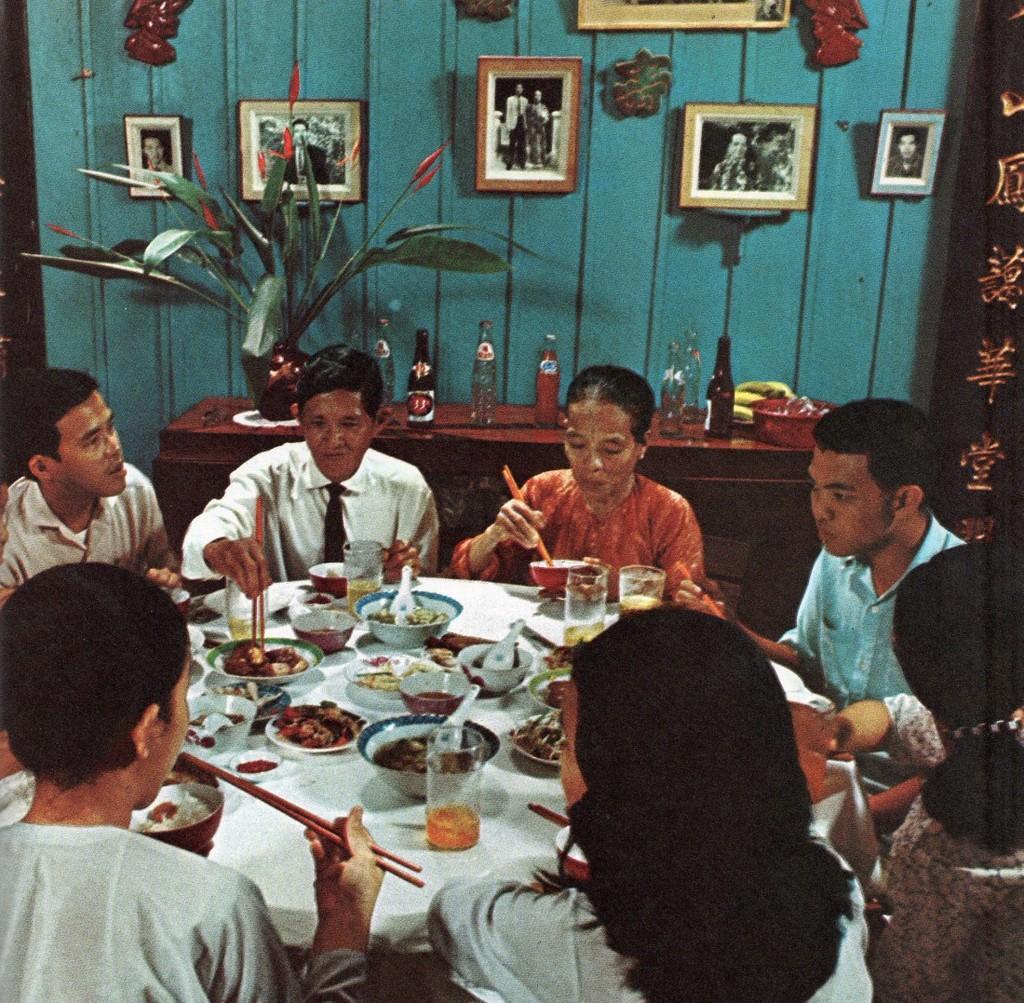Describe this image in one or two sentences. A group of people are having dinner together. There are dishes on the dining table behind them there is a wall,photo frames. 